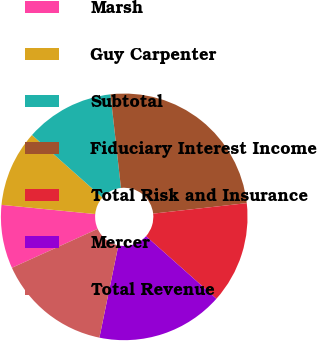Convert chart. <chart><loc_0><loc_0><loc_500><loc_500><pie_chart><fcel>Marsh<fcel>Guy Carpenter<fcel>Subtotal<fcel>Fiduciary Interest Income<fcel>Total Risk and Insurance<fcel>Mercer<fcel>Total Revenue<nl><fcel>8.33%<fcel>10.0%<fcel>11.67%<fcel>25.0%<fcel>13.33%<fcel>16.67%<fcel>15.0%<nl></chart> 